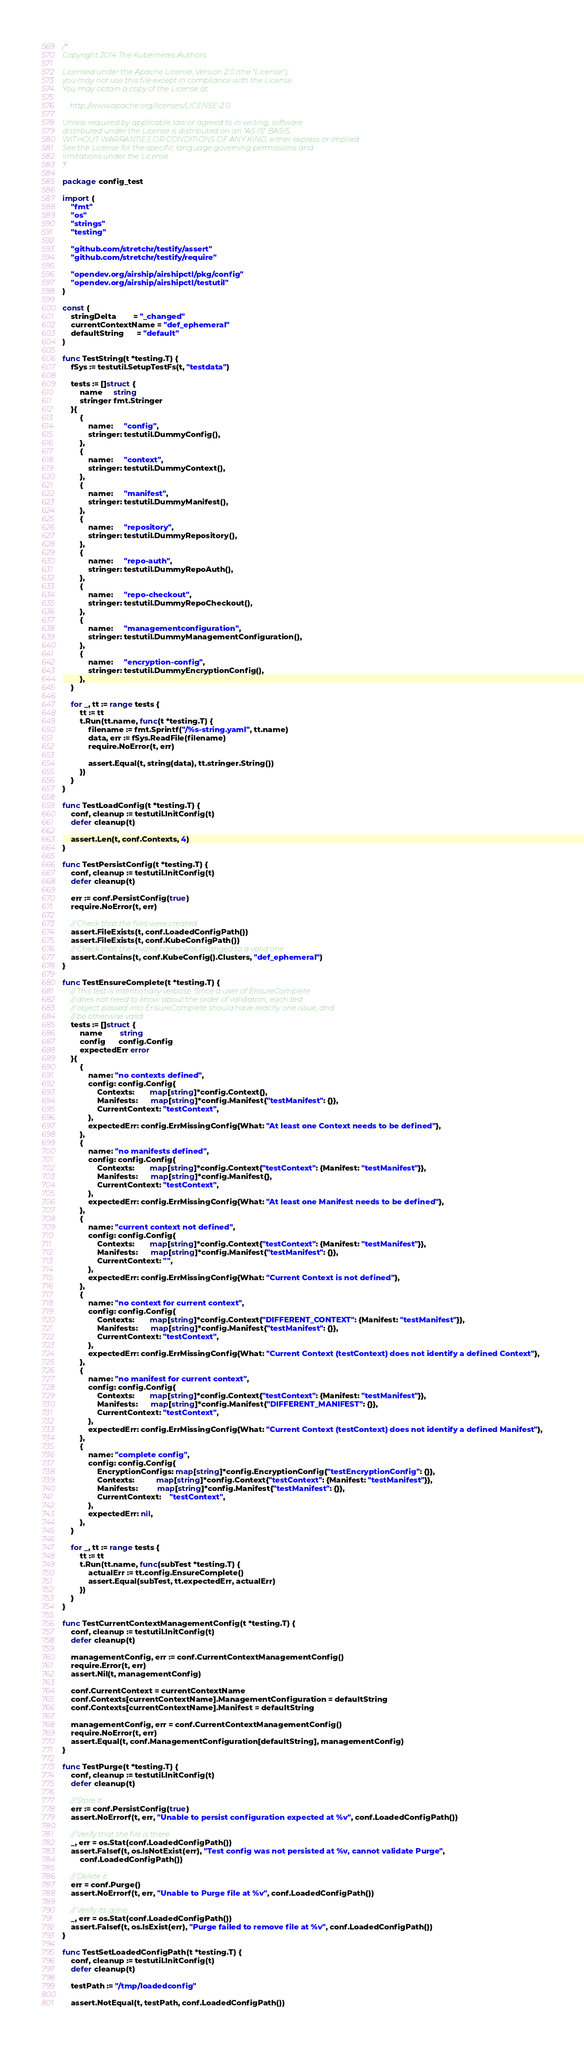<code> <loc_0><loc_0><loc_500><loc_500><_Go_>/*
Copyright 2014 The Kubernetes Authors.

Licensed under the Apache License, Version 2.0 (the "License");
you may not use this file except in compliance with the License.
You may obtain a copy of the License at

    http://www.apache.org/licenses/LICENSE-2.0

Unless required by applicable law or agreed to in writing, software
distributed under the License is distributed on an "AS IS" BASIS,
WITHOUT WARRANTIES OR CONDITIONS OF ANY KIND, either express or implied.
See the License for the specific language governing permissions and
limitations under the License.
*/

package config_test

import (
	"fmt"
	"os"
	"strings"
	"testing"

	"github.com/stretchr/testify/assert"
	"github.com/stretchr/testify/require"

	"opendev.org/airship/airshipctl/pkg/config"
	"opendev.org/airship/airshipctl/testutil"
)

const (
	stringDelta        = "_changed"
	currentContextName = "def_ephemeral"
	defaultString      = "default"
)

func TestString(t *testing.T) {
	fSys := testutil.SetupTestFs(t, "testdata")

	tests := []struct {
		name     string
		stringer fmt.Stringer
	}{
		{
			name:     "config",
			stringer: testutil.DummyConfig(),
		},
		{
			name:     "context",
			stringer: testutil.DummyContext(),
		},
		{
			name:     "manifest",
			stringer: testutil.DummyManifest(),
		},
		{
			name:     "repository",
			stringer: testutil.DummyRepository(),
		},
		{
			name:     "repo-auth",
			stringer: testutil.DummyRepoAuth(),
		},
		{
			name:     "repo-checkout",
			stringer: testutil.DummyRepoCheckout(),
		},
		{
			name:     "managementconfiguration",
			stringer: testutil.DummyManagementConfiguration(),
		},
		{
			name:     "encryption-config",
			stringer: testutil.DummyEncryptionConfig(),
		},
	}

	for _, tt := range tests {
		tt := tt
		t.Run(tt.name, func(t *testing.T) {
			filename := fmt.Sprintf("/%s-string.yaml", tt.name)
			data, err := fSys.ReadFile(filename)
			require.NoError(t, err)

			assert.Equal(t, string(data), tt.stringer.String())
		})
	}
}

func TestLoadConfig(t *testing.T) {
	conf, cleanup := testutil.InitConfig(t)
	defer cleanup(t)

	assert.Len(t, conf.Contexts, 4)
}

func TestPersistConfig(t *testing.T) {
	conf, cleanup := testutil.InitConfig(t)
	defer cleanup(t)

	err := conf.PersistConfig(true)
	require.NoError(t, err)

	// Check that the files were created
	assert.FileExists(t, conf.LoadedConfigPath())
	assert.FileExists(t, conf.KubeConfigPath())
	// Check that the invalid name was changed to a valid one
	assert.Contains(t, conf.KubeConfig().Clusters, "def_ephemeral")
}

func TestEnsureComplete(t *testing.T) {
	// This test is intentionally verbose. Since a user of EnsureComplete
	// does not need to know about the order of validation, each test
	// object passed into EnsureComplete should have exactly one issue, and
	// be otherwise valid
	tests := []struct {
		name        string
		config      config.Config
		expectedErr error
	}{
		{
			name: "no contexts defined",
			config: config.Config{
				Contexts:       map[string]*config.Context{},
				Manifests:      map[string]*config.Manifest{"testManifest": {}},
				CurrentContext: "testContext",
			},
			expectedErr: config.ErrMissingConfig{What: "At least one Context needs to be defined"},
		},
		{
			name: "no manifests defined",
			config: config.Config{
				Contexts:       map[string]*config.Context{"testContext": {Manifest: "testManifest"}},
				Manifests:      map[string]*config.Manifest{},
				CurrentContext: "testContext",
			},
			expectedErr: config.ErrMissingConfig{What: "At least one Manifest needs to be defined"},
		},
		{
			name: "current context not defined",
			config: config.Config{
				Contexts:       map[string]*config.Context{"testContext": {Manifest: "testManifest"}},
				Manifests:      map[string]*config.Manifest{"testManifest": {}},
				CurrentContext: "",
			},
			expectedErr: config.ErrMissingConfig{What: "Current Context is not defined"},
		},
		{
			name: "no context for current context",
			config: config.Config{
				Contexts:       map[string]*config.Context{"DIFFERENT_CONTEXT": {Manifest: "testManifest"}},
				Manifests:      map[string]*config.Manifest{"testManifest": {}},
				CurrentContext: "testContext",
			},
			expectedErr: config.ErrMissingConfig{What: "Current Context (testContext) does not identify a defined Context"},
		},
		{
			name: "no manifest for current context",
			config: config.Config{
				Contexts:       map[string]*config.Context{"testContext": {Manifest: "testManifest"}},
				Manifests:      map[string]*config.Manifest{"DIFFERENT_MANIFEST": {}},
				CurrentContext: "testContext",
			},
			expectedErr: config.ErrMissingConfig{What: "Current Context (testContext) does not identify a defined Manifest"},
		},
		{
			name: "complete config",
			config: config.Config{
				EncryptionConfigs: map[string]*config.EncryptionConfig{"testEncryptionConfig": {}},
				Contexts:          map[string]*config.Context{"testContext": {Manifest: "testManifest"}},
				Manifests:         map[string]*config.Manifest{"testManifest": {}},
				CurrentContext:    "testContext",
			},
			expectedErr: nil,
		},
	}

	for _, tt := range tests {
		tt := tt
		t.Run(tt.name, func(subTest *testing.T) {
			actualErr := tt.config.EnsureComplete()
			assert.Equal(subTest, tt.expectedErr, actualErr)
		})
	}
}

func TestCurrentContextManagementConfig(t *testing.T) {
	conf, cleanup := testutil.InitConfig(t)
	defer cleanup(t)

	managementConfig, err := conf.CurrentContextManagementConfig()
	require.Error(t, err)
	assert.Nil(t, managementConfig)

	conf.CurrentContext = currentContextName
	conf.Contexts[currentContextName].ManagementConfiguration = defaultString
	conf.Contexts[currentContextName].Manifest = defaultString

	managementConfig, err = conf.CurrentContextManagementConfig()
	require.NoError(t, err)
	assert.Equal(t, conf.ManagementConfiguration[defaultString], managementConfig)
}

func TestPurge(t *testing.T) {
	conf, cleanup := testutil.InitConfig(t)
	defer cleanup(t)

	// Store it
	err := conf.PersistConfig(true)
	assert.NoErrorf(t, err, "Unable to persist configuration expected at %v", conf.LoadedConfigPath())

	// Verify that the file is there
	_, err = os.Stat(conf.LoadedConfigPath())
	assert.Falsef(t, os.IsNotExist(err), "Test config was not persisted at %v, cannot validate Purge",
		conf.LoadedConfigPath())

	// Delete it
	err = conf.Purge()
	assert.NoErrorf(t, err, "Unable to Purge file at %v", conf.LoadedConfigPath())

	// Verify its gone
	_, err = os.Stat(conf.LoadedConfigPath())
	assert.Falsef(t, os.IsExist(err), "Purge failed to remove file at %v", conf.LoadedConfigPath())
}

func TestSetLoadedConfigPath(t *testing.T) {
	conf, cleanup := testutil.InitConfig(t)
	defer cleanup(t)

	testPath := "/tmp/loadedconfig"

	assert.NotEqual(t, testPath, conf.LoadedConfigPath())</code> 